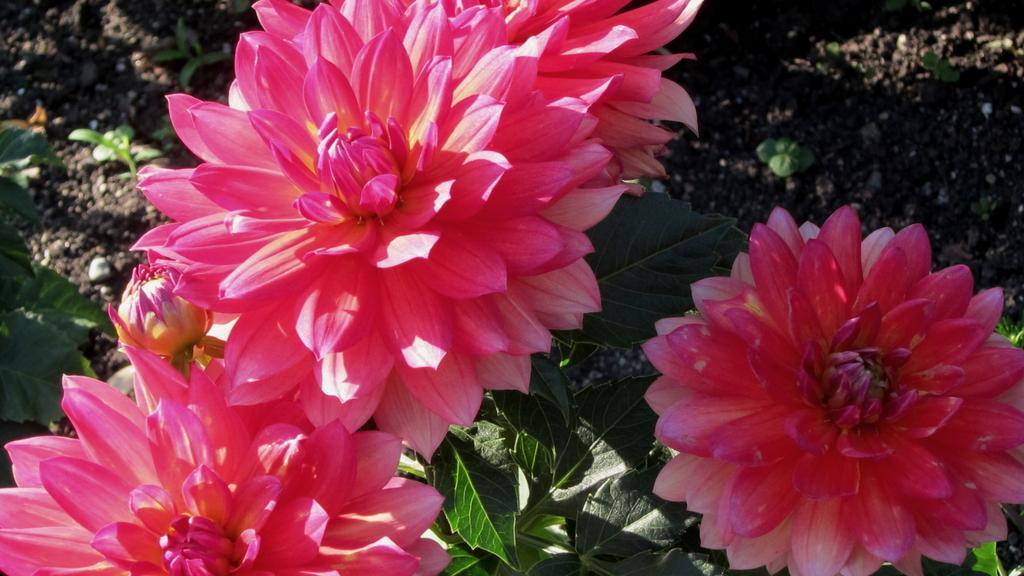Could you give a brief overview of what you see in this image? In this picture there are few flowers which are in pink color and there are few leaves below it. 